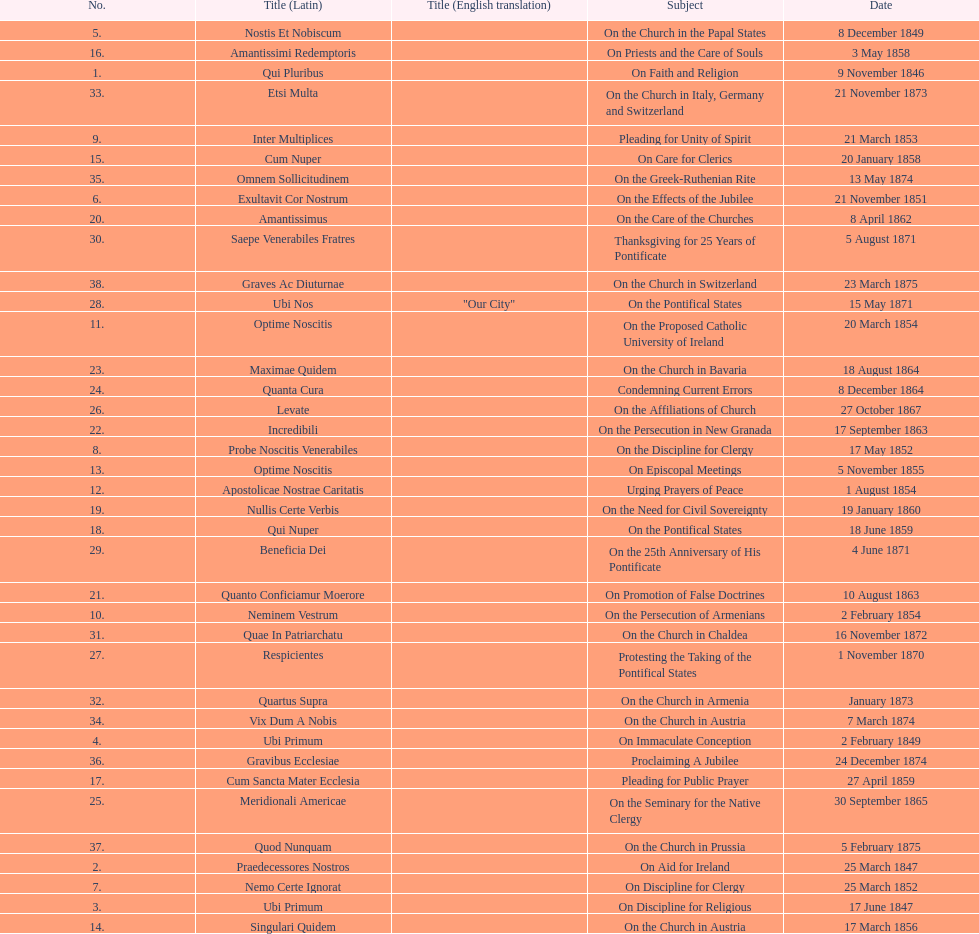Total number of encyclicals on churches . 11. 